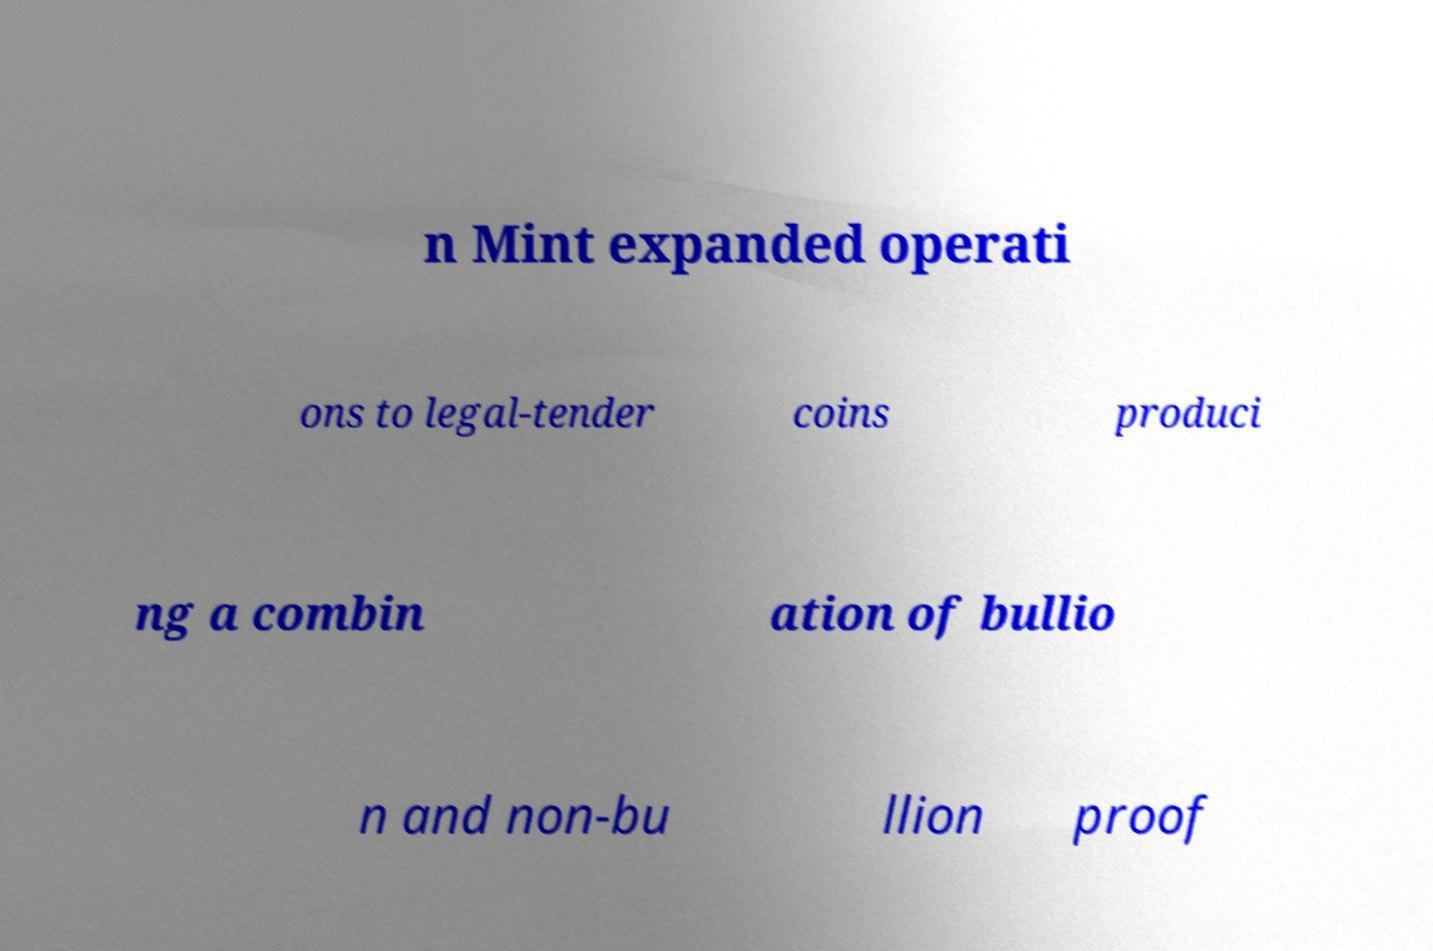Can you read and provide the text displayed in the image?This photo seems to have some interesting text. Can you extract and type it out for me? n Mint expanded operati ons to legal-tender coins produci ng a combin ation of bullio n and non-bu llion proof 